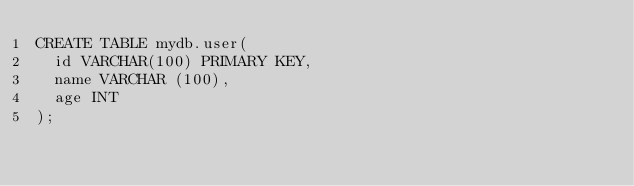Convert code to text. <code><loc_0><loc_0><loc_500><loc_500><_SQL_>CREATE TABLE mydb.user(
  id VARCHAR(100) PRIMARY KEY,
  name VARCHAR (100),
  age INT
);
</code> 